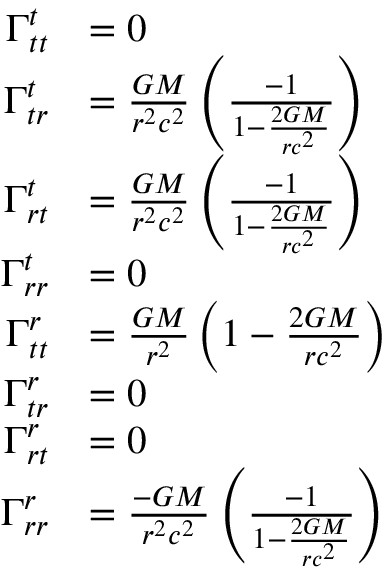Convert formula to latex. <formula><loc_0><loc_0><loc_500><loc_500>\begin{array} { r l } { \Gamma _ { t t } ^ { t } } & { = 0 } \\ { \Gamma _ { t r } ^ { t } } & { = \frac { G M } { r ^ { 2 } c ^ { 2 } } \left ( \frac { - 1 } { 1 - \frac { 2 G M } { r c ^ { 2 } } } \right ) } \\ { \Gamma _ { r t } ^ { t } } & { = \frac { G M } { r ^ { 2 } c ^ { 2 } } \left ( \frac { - 1 } { 1 - \frac { 2 G M } { r c ^ { 2 } } } \right ) } \\ { \Gamma _ { r r } ^ { t } } & { = 0 } \\ { \Gamma _ { t t } ^ { r } } & { = \frac { G M } { r ^ { 2 } } \left ( 1 - \frac { 2 G M } { r c ^ { 2 } } \right ) } \\ { \Gamma _ { t r } ^ { r } } & { = 0 } \\ { \Gamma _ { r t } ^ { r } } & { = 0 } \\ { \Gamma _ { r r } ^ { r } } & { = \frac { - G M } { r ^ { 2 } c ^ { 2 } } \left ( \frac { - 1 } { 1 - \frac { 2 G M } { r c ^ { 2 } } } \right ) } \end{array}</formula> 